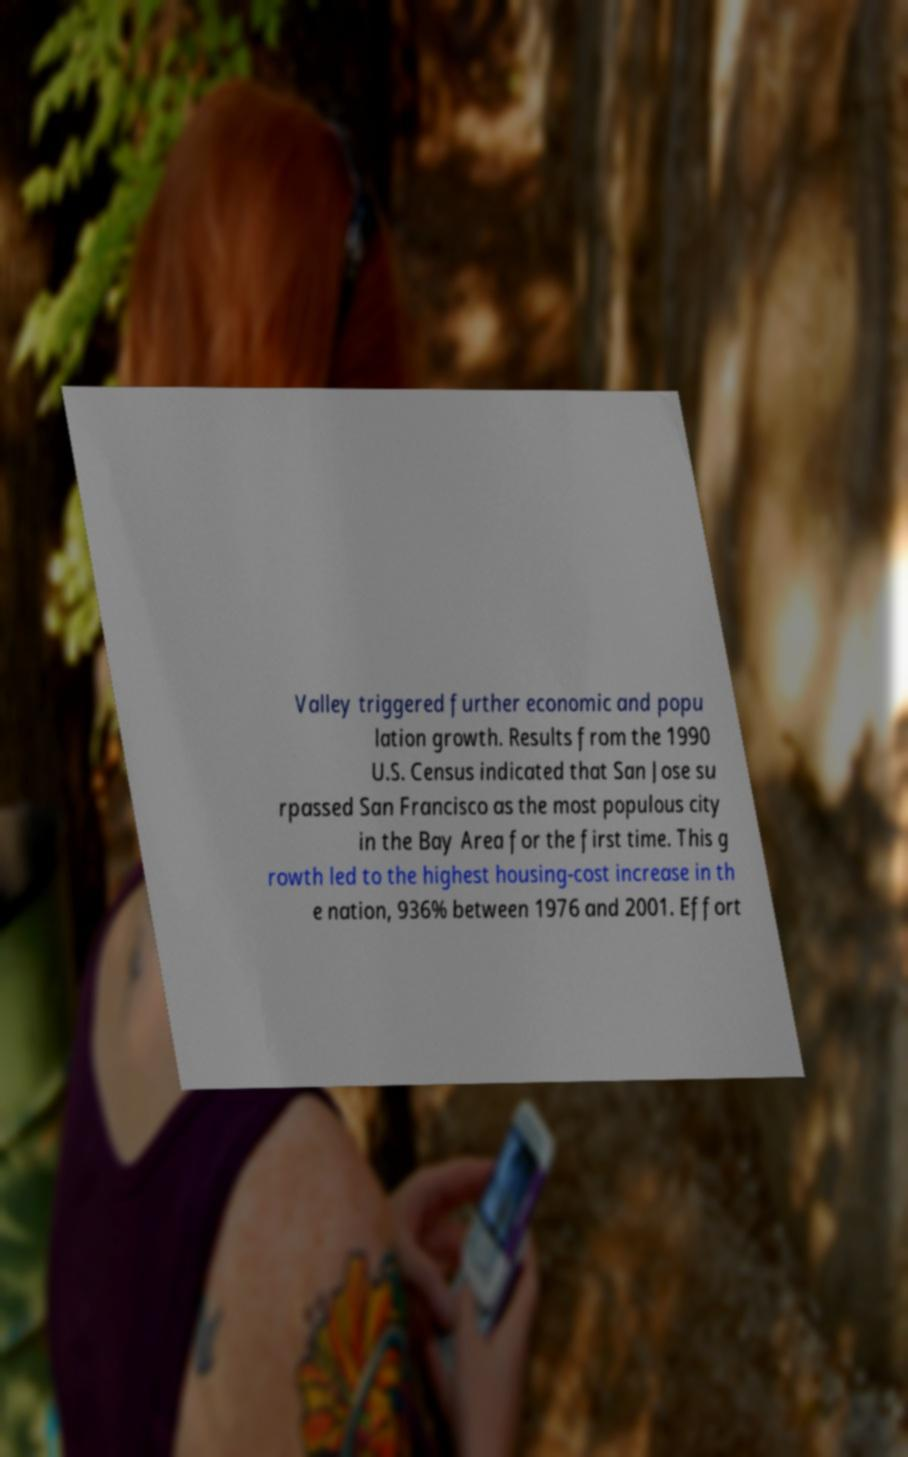There's text embedded in this image that I need extracted. Can you transcribe it verbatim? Valley triggered further economic and popu lation growth. Results from the 1990 U.S. Census indicated that San Jose su rpassed San Francisco as the most populous city in the Bay Area for the first time. This g rowth led to the highest housing-cost increase in th e nation, 936% between 1976 and 2001. Effort 